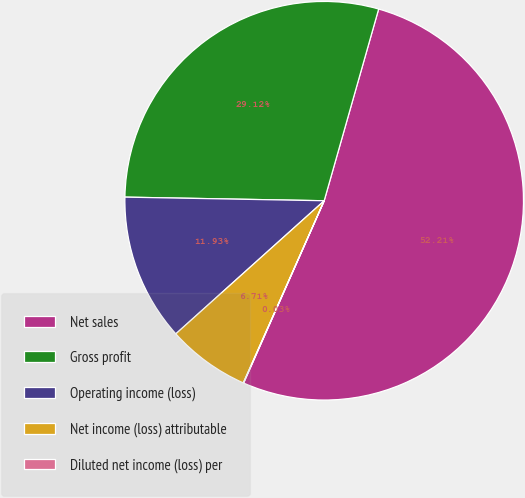Convert chart. <chart><loc_0><loc_0><loc_500><loc_500><pie_chart><fcel>Net sales<fcel>Gross profit<fcel>Operating income (loss)<fcel>Net income (loss) attributable<fcel>Diluted net income (loss) per<nl><fcel>52.22%<fcel>29.12%<fcel>11.93%<fcel>6.71%<fcel>0.03%<nl></chart> 